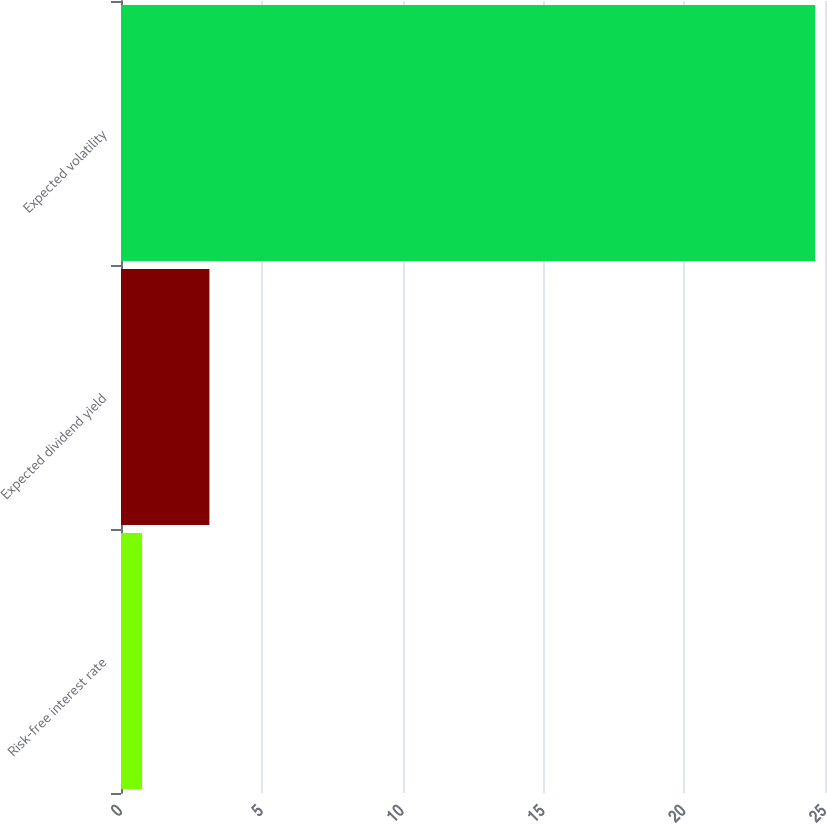Convert chart to OTSL. <chart><loc_0><loc_0><loc_500><loc_500><bar_chart><fcel>Risk-free interest rate<fcel>Expected dividend yield<fcel>Expected volatility<nl><fcel>0.75<fcel>3.14<fcel>24.65<nl></chart> 